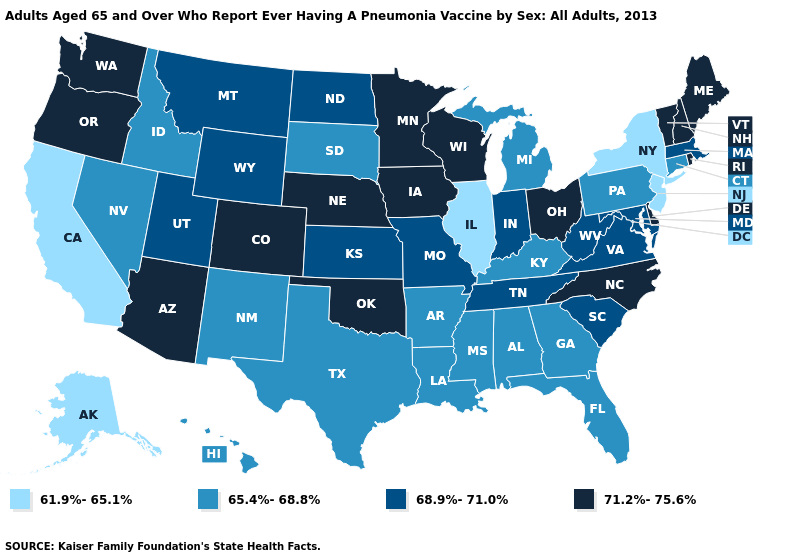Which states have the lowest value in the MidWest?
Concise answer only. Illinois. Among the states that border North Carolina , does Georgia have the highest value?
Quick response, please. No. Name the states that have a value in the range 61.9%-65.1%?
Be succinct. Alaska, California, Illinois, New Jersey, New York. Among the states that border Utah , does Nevada have the highest value?
Write a very short answer. No. Does Montana have a higher value than Delaware?
Give a very brief answer. No. Which states have the lowest value in the USA?
Be succinct. Alaska, California, Illinois, New Jersey, New York. What is the highest value in states that border Michigan?
Quick response, please. 71.2%-75.6%. Does Michigan have a lower value than Tennessee?
Give a very brief answer. Yes. Does North Dakota have a higher value than New Mexico?
Write a very short answer. Yes. Among the states that border Kentucky , does Ohio have the highest value?
Keep it brief. Yes. What is the lowest value in the USA?
Keep it brief. 61.9%-65.1%. Name the states that have a value in the range 61.9%-65.1%?
Short answer required. Alaska, California, Illinois, New Jersey, New York. What is the highest value in the USA?
Answer briefly. 71.2%-75.6%. What is the value of Louisiana?
Short answer required. 65.4%-68.8%. Name the states that have a value in the range 61.9%-65.1%?
Give a very brief answer. Alaska, California, Illinois, New Jersey, New York. 